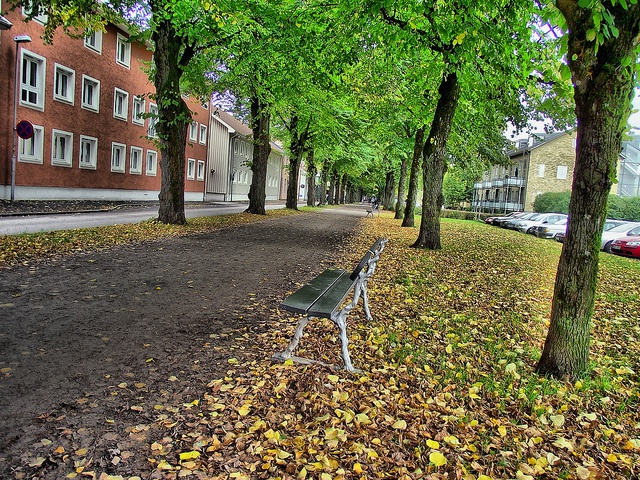Describe the objects in this image and their specific colors. I can see bench in aquamarine, gray, black, darkgray, and tan tones, car in aquamarine, black, lightgray, maroon, and darkgray tones, car in aquamarine, white, lightblue, darkgray, and gray tones, car in aquamarine, white, gray, black, and lightblue tones, and car in aquamarine, white, black, darkgray, and gray tones in this image. 